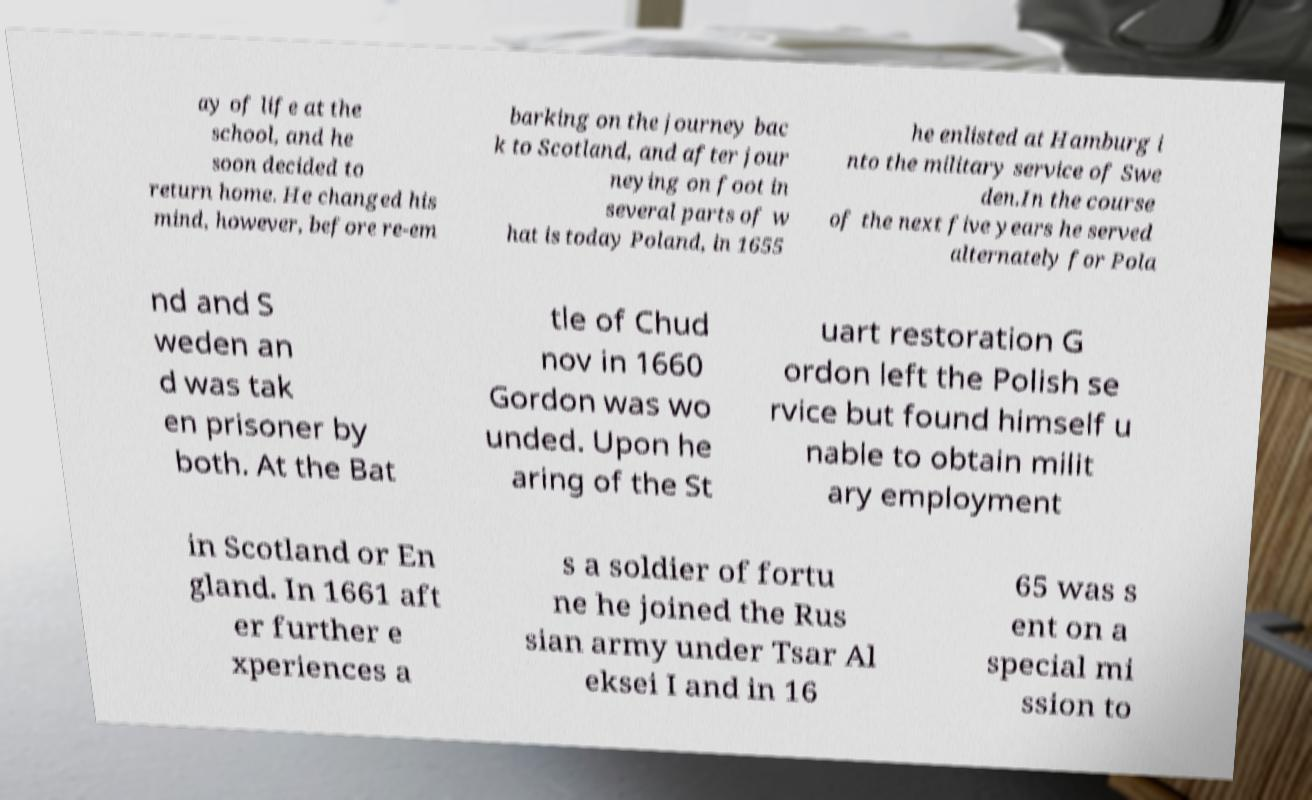What messages or text are displayed in this image? I need them in a readable, typed format. ay of life at the school, and he soon decided to return home. He changed his mind, however, before re-em barking on the journey bac k to Scotland, and after jour neying on foot in several parts of w hat is today Poland, in 1655 he enlisted at Hamburg i nto the military service of Swe den.In the course of the next five years he served alternately for Pola nd and S weden an d was tak en prisoner by both. At the Bat tle of Chud nov in 1660 Gordon was wo unded. Upon he aring of the St uart restoration G ordon left the Polish se rvice but found himself u nable to obtain milit ary employment in Scotland or En gland. In 1661 aft er further e xperiences a s a soldier of fortu ne he joined the Rus sian army under Tsar Al eksei I and in 16 65 was s ent on a special mi ssion to 